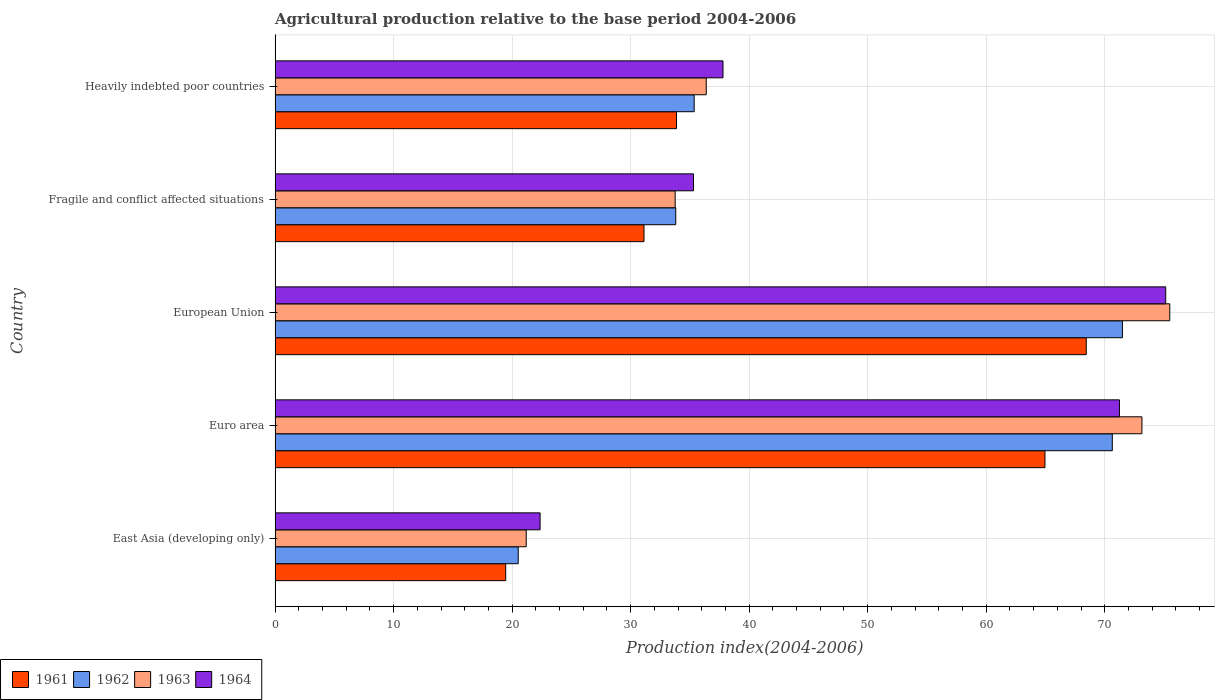How many different coloured bars are there?
Keep it short and to the point. 4. How many groups of bars are there?
Provide a succinct answer. 5. Are the number of bars on each tick of the Y-axis equal?
Provide a succinct answer. Yes. How many bars are there on the 3rd tick from the top?
Your response must be concise. 4. What is the label of the 2nd group of bars from the top?
Your answer should be compact. Fragile and conflict affected situations. What is the agricultural production index in 1963 in Euro area?
Keep it short and to the point. 73.14. Across all countries, what is the maximum agricultural production index in 1963?
Provide a succinct answer. 75.49. Across all countries, what is the minimum agricultural production index in 1961?
Offer a very short reply. 19.46. In which country was the agricultural production index in 1962 maximum?
Ensure brevity in your answer.  European Union. In which country was the agricultural production index in 1962 minimum?
Give a very brief answer. East Asia (developing only). What is the total agricultural production index in 1961 in the graph?
Your answer should be compact. 217.86. What is the difference between the agricultural production index in 1962 in Euro area and that in European Union?
Ensure brevity in your answer.  -0.85. What is the difference between the agricultural production index in 1961 in Heavily indebted poor countries and the agricultural production index in 1964 in East Asia (developing only)?
Offer a very short reply. 11.51. What is the average agricultural production index in 1962 per country?
Your response must be concise. 46.36. What is the difference between the agricultural production index in 1962 and agricultural production index in 1963 in Fragile and conflict affected situations?
Give a very brief answer. 0.05. What is the ratio of the agricultural production index in 1961 in East Asia (developing only) to that in Heavily indebted poor countries?
Your answer should be very brief. 0.57. What is the difference between the highest and the second highest agricultural production index in 1963?
Your answer should be very brief. 2.35. What is the difference between the highest and the lowest agricultural production index in 1962?
Make the answer very short. 50.98. In how many countries, is the agricultural production index in 1964 greater than the average agricultural production index in 1964 taken over all countries?
Your response must be concise. 2. Is the sum of the agricultural production index in 1963 in Euro area and European Union greater than the maximum agricultural production index in 1964 across all countries?
Offer a terse response. Yes. Is it the case that in every country, the sum of the agricultural production index in 1963 and agricultural production index in 1962 is greater than the sum of agricultural production index in 1961 and agricultural production index in 1964?
Make the answer very short. No. What does the 1st bar from the top in European Union represents?
Keep it short and to the point. 1964. Is it the case that in every country, the sum of the agricultural production index in 1963 and agricultural production index in 1964 is greater than the agricultural production index in 1962?
Make the answer very short. Yes. How many countries are there in the graph?
Provide a succinct answer. 5. What is the difference between two consecutive major ticks on the X-axis?
Offer a terse response. 10. Are the values on the major ticks of X-axis written in scientific E-notation?
Your answer should be very brief. No. Does the graph contain any zero values?
Offer a terse response. No. Does the graph contain grids?
Provide a succinct answer. Yes. Where does the legend appear in the graph?
Keep it short and to the point. Bottom left. How are the legend labels stacked?
Keep it short and to the point. Horizontal. What is the title of the graph?
Your answer should be very brief. Agricultural production relative to the base period 2004-2006. Does "1969" appear as one of the legend labels in the graph?
Your answer should be compact. No. What is the label or title of the X-axis?
Your answer should be very brief. Production index(2004-2006). What is the Production index(2004-2006) in 1961 in East Asia (developing only)?
Your answer should be very brief. 19.46. What is the Production index(2004-2006) of 1962 in East Asia (developing only)?
Keep it short and to the point. 20.51. What is the Production index(2004-2006) of 1963 in East Asia (developing only)?
Give a very brief answer. 21.19. What is the Production index(2004-2006) of 1964 in East Asia (developing only)?
Your answer should be very brief. 22.36. What is the Production index(2004-2006) in 1961 in Euro area?
Your answer should be compact. 64.96. What is the Production index(2004-2006) in 1962 in Euro area?
Give a very brief answer. 70.64. What is the Production index(2004-2006) in 1963 in Euro area?
Your answer should be very brief. 73.14. What is the Production index(2004-2006) of 1964 in Euro area?
Your answer should be compact. 71.24. What is the Production index(2004-2006) of 1961 in European Union?
Offer a terse response. 68.44. What is the Production index(2004-2006) of 1962 in European Union?
Offer a very short reply. 71.49. What is the Production index(2004-2006) of 1963 in European Union?
Your answer should be very brief. 75.49. What is the Production index(2004-2006) in 1964 in European Union?
Offer a very short reply. 75.15. What is the Production index(2004-2006) of 1961 in Fragile and conflict affected situations?
Your answer should be very brief. 31.13. What is the Production index(2004-2006) of 1962 in Fragile and conflict affected situations?
Offer a very short reply. 33.81. What is the Production index(2004-2006) of 1963 in Fragile and conflict affected situations?
Your answer should be compact. 33.76. What is the Production index(2004-2006) of 1964 in Fragile and conflict affected situations?
Make the answer very short. 35.31. What is the Production index(2004-2006) in 1961 in Heavily indebted poor countries?
Provide a succinct answer. 33.87. What is the Production index(2004-2006) in 1962 in Heavily indebted poor countries?
Your answer should be compact. 35.36. What is the Production index(2004-2006) in 1963 in Heavily indebted poor countries?
Keep it short and to the point. 36.38. What is the Production index(2004-2006) of 1964 in Heavily indebted poor countries?
Your answer should be compact. 37.79. Across all countries, what is the maximum Production index(2004-2006) of 1961?
Ensure brevity in your answer.  68.44. Across all countries, what is the maximum Production index(2004-2006) of 1962?
Ensure brevity in your answer.  71.49. Across all countries, what is the maximum Production index(2004-2006) of 1963?
Offer a terse response. 75.49. Across all countries, what is the maximum Production index(2004-2006) of 1964?
Provide a short and direct response. 75.15. Across all countries, what is the minimum Production index(2004-2006) of 1961?
Your answer should be compact. 19.46. Across all countries, what is the minimum Production index(2004-2006) in 1962?
Your answer should be compact. 20.51. Across all countries, what is the minimum Production index(2004-2006) of 1963?
Offer a terse response. 21.19. Across all countries, what is the minimum Production index(2004-2006) in 1964?
Your answer should be very brief. 22.36. What is the total Production index(2004-2006) of 1961 in the graph?
Give a very brief answer. 217.86. What is the total Production index(2004-2006) of 1962 in the graph?
Your answer should be very brief. 231.82. What is the total Production index(2004-2006) in 1963 in the graph?
Keep it short and to the point. 239.95. What is the total Production index(2004-2006) in 1964 in the graph?
Your answer should be very brief. 241.85. What is the difference between the Production index(2004-2006) of 1961 in East Asia (developing only) and that in Euro area?
Offer a terse response. -45.5. What is the difference between the Production index(2004-2006) in 1962 in East Asia (developing only) and that in Euro area?
Offer a very short reply. -50.13. What is the difference between the Production index(2004-2006) in 1963 in East Asia (developing only) and that in Euro area?
Your answer should be very brief. -51.95. What is the difference between the Production index(2004-2006) in 1964 in East Asia (developing only) and that in Euro area?
Provide a short and direct response. -48.88. What is the difference between the Production index(2004-2006) in 1961 in East Asia (developing only) and that in European Union?
Offer a very short reply. -48.98. What is the difference between the Production index(2004-2006) of 1962 in East Asia (developing only) and that in European Union?
Your answer should be compact. -50.98. What is the difference between the Production index(2004-2006) in 1963 in East Asia (developing only) and that in European Union?
Give a very brief answer. -54.3. What is the difference between the Production index(2004-2006) of 1964 in East Asia (developing only) and that in European Union?
Make the answer very short. -52.79. What is the difference between the Production index(2004-2006) of 1961 in East Asia (developing only) and that in Fragile and conflict affected situations?
Your response must be concise. -11.67. What is the difference between the Production index(2004-2006) of 1962 in East Asia (developing only) and that in Fragile and conflict affected situations?
Provide a short and direct response. -13.29. What is the difference between the Production index(2004-2006) of 1963 in East Asia (developing only) and that in Fragile and conflict affected situations?
Provide a succinct answer. -12.57. What is the difference between the Production index(2004-2006) of 1964 in East Asia (developing only) and that in Fragile and conflict affected situations?
Offer a terse response. -12.95. What is the difference between the Production index(2004-2006) in 1961 in East Asia (developing only) and that in Heavily indebted poor countries?
Ensure brevity in your answer.  -14.41. What is the difference between the Production index(2004-2006) in 1962 in East Asia (developing only) and that in Heavily indebted poor countries?
Provide a short and direct response. -14.85. What is the difference between the Production index(2004-2006) in 1963 in East Asia (developing only) and that in Heavily indebted poor countries?
Give a very brief answer. -15.19. What is the difference between the Production index(2004-2006) of 1964 in East Asia (developing only) and that in Heavily indebted poor countries?
Offer a terse response. -15.43. What is the difference between the Production index(2004-2006) of 1961 in Euro area and that in European Union?
Offer a very short reply. -3.48. What is the difference between the Production index(2004-2006) of 1962 in Euro area and that in European Union?
Your answer should be compact. -0.85. What is the difference between the Production index(2004-2006) in 1963 in Euro area and that in European Union?
Ensure brevity in your answer.  -2.35. What is the difference between the Production index(2004-2006) of 1964 in Euro area and that in European Union?
Offer a very short reply. -3.9. What is the difference between the Production index(2004-2006) in 1961 in Euro area and that in Fragile and conflict affected situations?
Give a very brief answer. 33.83. What is the difference between the Production index(2004-2006) of 1962 in Euro area and that in Fragile and conflict affected situations?
Your response must be concise. 36.83. What is the difference between the Production index(2004-2006) in 1963 in Euro area and that in Fragile and conflict affected situations?
Offer a very short reply. 39.38. What is the difference between the Production index(2004-2006) in 1964 in Euro area and that in Fragile and conflict affected situations?
Your response must be concise. 35.94. What is the difference between the Production index(2004-2006) of 1961 in Euro area and that in Heavily indebted poor countries?
Offer a very short reply. 31.09. What is the difference between the Production index(2004-2006) of 1962 in Euro area and that in Heavily indebted poor countries?
Offer a terse response. 35.28. What is the difference between the Production index(2004-2006) in 1963 in Euro area and that in Heavily indebted poor countries?
Give a very brief answer. 36.76. What is the difference between the Production index(2004-2006) of 1964 in Euro area and that in Heavily indebted poor countries?
Make the answer very short. 33.45. What is the difference between the Production index(2004-2006) of 1961 in European Union and that in Fragile and conflict affected situations?
Your answer should be very brief. 37.32. What is the difference between the Production index(2004-2006) in 1962 in European Union and that in Fragile and conflict affected situations?
Offer a very short reply. 37.69. What is the difference between the Production index(2004-2006) in 1963 in European Union and that in Fragile and conflict affected situations?
Your answer should be very brief. 41.73. What is the difference between the Production index(2004-2006) in 1964 in European Union and that in Fragile and conflict affected situations?
Keep it short and to the point. 39.84. What is the difference between the Production index(2004-2006) of 1961 in European Union and that in Heavily indebted poor countries?
Make the answer very short. 34.57. What is the difference between the Production index(2004-2006) of 1962 in European Union and that in Heavily indebted poor countries?
Your answer should be compact. 36.13. What is the difference between the Production index(2004-2006) in 1963 in European Union and that in Heavily indebted poor countries?
Your answer should be very brief. 39.11. What is the difference between the Production index(2004-2006) in 1964 in European Union and that in Heavily indebted poor countries?
Provide a short and direct response. 37.35. What is the difference between the Production index(2004-2006) of 1961 in Fragile and conflict affected situations and that in Heavily indebted poor countries?
Provide a succinct answer. -2.74. What is the difference between the Production index(2004-2006) of 1962 in Fragile and conflict affected situations and that in Heavily indebted poor countries?
Keep it short and to the point. -1.55. What is the difference between the Production index(2004-2006) in 1963 in Fragile and conflict affected situations and that in Heavily indebted poor countries?
Offer a terse response. -2.62. What is the difference between the Production index(2004-2006) in 1964 in Fragile and conflict affected situations and that in Heavily indebted poor countries?
Ensure brevity in your answer.  -2.49. What is the difference between the Production index(2004-2006) of 1961 in East Asia (developing only) and the Production index(2004-2006) of 1962 in Euro area?
Your answer should be compact. -51.18. What is the difference between the Production index(2004-2006) of 1961 in East Asia (developing only) and the Production index(2004-2006) of 1963 in Euro area?
Provide a succinct answer. -53.68. What is the difference between the Production index(2004-2006) of 1961 in East Asia (developing only) and the Production index(2004-2006) of 1964 in Euro area?
Provide a short and direct response. -51.78. What is the difference between the Production index(2004-2006) of 1962 in East Asia (developing only) and the Production index(2004-2006) of 1963 in Euro area?
Keep it short and to the point. -52.63. What is the difference between the Production index(2004-2006) in 1962 in East Asia (developing only) and the Production index(2004-2006) in 1964 in Euro area?
Provide a succinct answer. -50.73. What is the difference between the Production index(2004-2006) of 1963 in East Asia (developing only) and the Production index(2004-2006) of 1964 in Euro area?
Offer a terse response. -50.05. What is the difference between the Production index(2004-2006) of 1961 in East Asia (developing only) and the Production index(2004-2006) of 1962 in European Union?
Give a very brief answer. -52.04. What is the difference between the Production index(2004-2006) in 1961 in East Asia (developing only) and the Production index(2004-2006) in 1963 in European Union?
Your answer should be compact. -56.03. What is the difference between the Production index(2004-2006) in 1961 in East Asia (developing only) and the Production index(2004-2006) in 1964 in European Union?
Keep it short and to the point. -55.69. What is the difference between the Production index(2004-2006) of 1962 in East Asia (developing only) and the Production index(2004-2006) of 1963 in European Union?
Make the answer very short. -54.97. What is the difference between the Production index(2004-2006) in 1962 in East Asia (developing only) and the Production index(2004-2006) in 1964 in European Union?
Offer a terse response. -54.63. What is the difference between the Production index(2004-2006) in 1963 in East Asia (developing only) and the Production index(2004-2006) in 1964 in European Union?
Your response must be concise. -53.96. What is the difference between the Production index(2004-2006) in 1961 in East Asia (developing only) and the Production index(2004-2006) in 1962 in Fragile and conflict affected situations?
Your answer should be very brief. -14.35. What is the difference between the Production index(2004-2006) of 1961 in East Asia (developing only) and the Production index(2004-2006) of 1963 in Fragile and conflict affected situations?
Provide a short and direct response. -14.3. What is the difference between the Production index(2004-2006) of 1961 in East Asia (developing only) and the Production index(2004-2006) of 1964 in Fragile and conflict affected situations?
Give a very brief answer. -15.85. What is the difference between the Production index(2004-2006) of 1962 in East Asia (developing only) and the Production index(2004-2006) of 1963 in Fragile and conflict affected situations?
Give a very brief answer. -13.24. What is the difference between the Production index(2004-2006) in 1962 in East Asia (developing only) and the Production index(2004-2006) in 1964 in Fragile and conflict affected situations?
Ensure brevity in your answer.  -14.79. What is the difference between the Production index(2004-2006) in 1963 in East Asia (developing only) and the Production index(2004-2006) in 1964 in Fragile and conflict affected situations?
Offer a very short reply. -14.12. What is the difference between the Production index(2004-2006) in 1961 in East Asia (developing only) and the Production index(2004-2006) in 1962 in Heavily indebted poor countries?
Your response must be concise. -15.9. What is the difference between the Production index(2004-2006) in 1961 in East Asia (developing only) and the Production index(2004-2006) in 1963 in Heavily indebted poor countries?
Keep it short and to the point. -16.92. What is the difference between the Production index(2004-2006) in 1961 in East Asia (developing only) and the Production index(2004-2006) in 1964 in Heavily indebted poor countries?
Your response must be concise. -18.34. What is the difference between the Production index(2004-2006) of 1962 in East Asia (developing only) and the Production index(2004-2006) of 1963 in Heavily indebted poor countries?
Your response must be concise. -15.86. What is the difference between the Production index(2004-2006) in 1962 in East Asia (developing only) and the Production index(2004-2006) in 1964 in Heavily indebted poor countries?
Offer a terse response. -17.28. What is the difference between the Production index(2004-2006) in 1963 in East Asia (developing only) and the Production index(2004-2006) in 1964 in Heavily indebted poor countries?
Make the answer very short. -16.6. What is the difference between the Production index(2004-2006) in 1961 in Euro area and the Production index(2004-2006) in 1962 in European Union?
Provide a short and direct response. -6.54. What is the difference between the Production index(2004-2006) in 1961 in Euro area and the Production index(2004-2006) in 1963 in European Union?
Provide a succinct answer. -10.53. What is the difference between the Production index(2004-2006) of 1961 in Euro area and the Production index(2004-2006) of 1964 in European Union?
Keep it short and to the point. -10.19. What is the difference between the Production index(2004-2006) in 1962 in Euro area and the Production index(2004-2006) in 1963 in European Union?
Give a very brief answer. -4.85. What is the difference between the Production index(2004-2006) of 1962 in Euro area and the Production index(2004-2006) of 1964 in European Union?
Offer a very short reply. -4.5. What is the difference between the Production index(2004-2006) of 1963 in Euro area and the Production index(2004-2006) of 1964 in European Union?
Keep it short and to the point. -2.01. What is the difference between the Production index(2004-2006) in 1961 in Euro area and the Production index(2004-2006) in 1962 in Fragile and conflict affected situations?
Provide a succinct answer. 31.15. What is the difference between the Production index(2004-2006) of 1961 in Euro area and the Production index(2004-2006) of 1963 in Fragile and conflict affected situations?
Provide a short and direct response. 31.2. What is the difference between the Production index(2004-2006) of 1961 in Euro area and the Production index(2004-2006) of 1964 in Fragile and conflict affected situations?
Offer a terse response. 29.65. What is the difference between the Production index(2004-2006) of 1962 in Euro area and the Production index(2004-2006) of 1963 in Fragile and conflict affected situations?
Offer a terse response. 36.88. What is the difference between the Production index(2004-2006) of 1962 in Euro area and the Production index(2004-2006) of 1964 in Fragile and conflict affected situations?
Your response must be concise. 35.34. What is the difference between the Production index(2004-2006) of 1963 in Euro area and the Production index(2004-2006) of 1964 in Fragile and conflict affected situations?
Provide a succinct answer. 37.83. What is the difference between the Production index(2004-2006) in 1961 in Euro area and the Production index(2004-2006) in 1962 in Heavily indebted poor countries?
Ensure brevity in your answer.  29.6. What is the difference between the Production index(2004-2006) in 1961 in Euro area and the Production index(2004-2006) in 1963 in Heavily indebted poor countries?
Keep it short and to the point. 28.58. What is the difference between the Production index(2004-2006) of 1961 in Euro area and the Production index(2004-2006) of 1964 in Heavily indebted poor countries?
Your answer should be very brief. 27.17. What is the difference between the Production index(2004-2006) of 1962 in Euro area and the Production index(2004-2006) of 1963 in Heavily indebted poor countries?
Provide a short and direct response. 34.26. What is the difference between the Production index(2004-2006) of 1962 in Euro area and the Production index(2004-2006) of 1964 in Heavily indebted poor countries?
Ensure brevity in your answer.  32.85. What is the difference between the Production index(2004-2006) in 1963 in Euro area and the Production index(2004-2006) in 1964 in Heavily indebted poor countries?
Keep it short and to the point. 35.35. What is the difference between the Production index(2004-2006) in 1961 in European Union and the Production index(2004-2006) in 1962 in Fragile and conflict affected situations?
Your response must be concise. 34.64. What is the difference between the Production index(2004-2006) in 1961 in European Union and the Production index(2004-2006) in 1963 in Fragile and conflict affected situations?
Give a very brief answer. 34.69. What is the difference between the Production index(2004-2006) of 1961 in European Union and the Production index(2004-2006) of 1964 in Fragile and conflict affected situations?
Provide a short and direct response. 33.14. What is the difference between the Production index(2004-2006) in 1962 in European Union and the Production index(2004-2006) in 1963 in Fragile and conflict affected situations?
Ensure brevity in your answer.  37.74. What is the difference between the Production index(2004-2006) of 1962 in European Union and the Production index(2004-2006) of 1964 in Fragile and conflict affected situations?
Make the answer very short. 36.19. What is the difference between the Production index(2004-2006) of 1963 in European Union and the Production index(2004-2006) of 1964 in Fragile and conflict affected situations?
Keep it short and to the point. 40.18. What is the difference between the Production index(2004-2006) of 1961 in European Union and the Production index(2004-2006) of 1962 in Heavily indebted poor countries?
Give a very brief answer. 33.08. What is the difference between the Production index(2004-2006) of 1961 in European Union and the Production index(2004-2006) of 1963 in Heavily indebted poor countries?
Ensure brevity in your answer.  32.06. What is the difference between the Production index(2004-2006) in 1961 in European Union and the Production index(2004-2006) in 1964 in Heavily indebted poor countries?
Provide a short and direct response. 30.65. What is the difference between the Production index(2004-2006) in 1962 in European Union and the Production index(2004-2006) in 1963 in Heavily indebted poor countries?
Provide a short and direct response. 35.12. What is the difference between the Production index(2004-2006) of 1962 in European Union and the Production index(2004-2006) of 1964 in Heavily indebted poor countries?
Ensure brevity in your answer.  33.7. What is the difference between the Production index(2004-2006) of 1963 in European Union and the Production index(2004-2006) of 1964 in Heavily indebted poor countries?
Your answer should be very brief. 37.69. What is the difference between the Production index(2004-2006) in 1961 in Fragile and conflict affected situations and the Production index(2004-2006) in 1962 in Heavily indebted poor countries?
Provide a succinct answer. -4.23. What is the difference between the Production index(2004-2006) in 1961 in Fragile and conflict affected situations and the Production index(2004-2006) in 1963 in Heavily indebted poor countries?
Provide a succinct answer. -5.25. What is the difference between the Production index(2004-2006) of 1961 in Fragile and conflict affected situations and the Production index(2004-2006) of 1964 in Heavily indebted poor countries?
Your answer should be very brief. -6.67. What is the difference between the Production index(2004-2006) of 1962 in Fragile and conflict affected situations and the Production index(2004-2006) of 1963 in Heavily indebted poor countries?
Ensure brevity in your answer.  -2.57. What is the difference between the Production index(2004-2006) of 1962 in Fragile and conflict affected situations and the Production index(2004-2006) of 1964 in Heavily indebted poor countries?
Keep it short and to the point. -3.99. What is the difference between the Production index(2004-2006) in 1963 in Fragile and conflict affected situations and the Production index(2004-2006) in 1964 in Heavily indebted poor countries?
Provide a succinct answer. -4.04. What is the average Production index(2004-2006) of 1961 per country?
Your answer should be very brief. 43.57. What is the average Production index(2004-2006) in 1962 per country?
Give a very brief answer. 46.36. What is the average Production index(2004-2006) of 1963 per country?
Your response must be concise. 47.99. What is the average Production index(2004-2006) in 1964 per country?
Keep it short and to the point. 48.37. What is the difference between the Production index(2004-2006) in 1961 and Production index(2004-2006) in 1962 in East Asia (developing only)?
Provide a succinct answer. -1.06. What is the difference between the Production index(2004-2006) of 1961 and Production index(2004-2006) of 1963 in East Asia (developing only)?
Provide a short and direct response. -1.73. What is the difference between the Production index(2004-2006) in 1961 and Production index(2004-2006) in 1964 in East Asia (developing only)?
Offer a terse response. -2.9. What is the difference between the Production index(2004-2006) of 1962 and Production index(2004-2006) of 1963 in East Asia (developing only)?
Give a very brief answer. -0.68. What is the difference between the Production index(2004-2006) in 1962 and Production index(2004-2006) in 1964 in East Asia (developing only)?
Your answer should be very brief. -1.85. What is the difference between the Production index(2004-2006) in 1963 and Production index(2004-2006) in 1964 in East Asia (developing only)?
Your answer should be compact. -1.17. What is the difference between the Production index(2004-2006) in 1961 and Production index(2004-2006) in 1962 in Euro area?
Offer a terse response. -5.68. What is the difference between the Production index(2004-2006) of 1961 and Production index(2004-2006) of 1963 in Euro area?
Offer a terse response. -8.18. What is the difference between the Production index(2004-2006) in 1961 and Production index(2004-2006) in 1964 in Euro area?
Ensure brevity in your answer.  -6.28. What is the difference between the Production index(2004-2006) of 1962 and Production index(2004-2006) of 1963 in Euro area?
Provide a succinct answer. -2.5. What is the difference between the Production index(2004-2006) of 1962 and Production index(2004-2006) of 1964 in Euro area?
Provide a short and direct response. -0.6. What is the difference between the Production index(2004-2006) in 1963 and Production index(2004-2006) in 1964 in Euro area?
Provide a succinct answer. 1.9. What is the difference between the Production index(2004-2006) of 1961 and Production index(2004-2006) of 1962 in European Union?
Your answer should be compact. -3.05. What is the difference between the Production index(2004-2006) of 1961 and Production index(2004-2006) of 1963 in European Union?
Provide a succinct answer. -7.05. What is the difference between the Production index(2004-2006) of 1961 and Production index(2004-2006) of 1964 in European Union?
Give a very brief answer. -6.7. What is the difference between the Production index(2004-2006) of 1962 and Production index(2004-2006) of 1963 in European Union?
Provide a short and direct response. -3.99. What is the difference between the Production index(2004-2006) of 1962 and Production index(2004-2006) of 1964 in European Union?
Provide a short and direct response. -3.65. What is the difference between the Production index(2004-2006) of 1963 and Production index(2004-2006) of 1964 in European Union?
Your response must be concise. 0.34. What is the difference between the Production index(2004-2006) in 1961 and Production index(2004-2006) in 1962 in Fragile and conflict affected situations?
Give a very brief answer. -2.68. What is the difference between the Production index(2004-2006) in 1961 and Production index(2004-2006) in 1963 in Fragile and conflict affected situations?
Keep it short and to the point. -2.63. What is the difference between the Production index(2004-2006) in 1961 and Production index(2004-2006) in 1964 in Fragile and conflict affected situations?
Offer a terse response. -4.18. What is the difference between the Production index(2004-2006) in 1962 and Production index(2004-2006) in 1963 in Fragile and conflict affected situations?
Your answer should be compact. 0.05. What is the difference between the Production index(2004-2006) of 1962 and Production index(2004-2006) of 1964 in Fragile and conflict affected situations?
Offer a terse response. -1.5. What is the difference between the Production index(2004-2006) of 1963 and Production index(2004-2006) of 1964 in Fragile and conflict affected situations?
Give a very brief answer. -1.55. What is the difference between the Production index(2004-2006) of 1961 and Production index(2004-2006) of 1962 in Heavily indebted poor countries?
Ensure brevity in your answer.  -1.49. What is the difference between the Production index(2004-2006) of 1961 and Production index(2004-2006) of 1963 in Heavily indebted poor countries?
Make the answer very short. -2.51. What is the difference between the Production index(2004-2006) of 1961 and Production index(2004-2006) of 1964 in Heavily indebted poor countries?
Make the answer very short. -3.92. What is the difference between the Production index(2004-2006) in 1962 and Production index(2004-2006) in 1963 in Heavily indebted poor countries?
Offer a very short reply. -1.02. What is the difference between the Production index(2004-2006) in 1962 and Production index(2004-2006) in 1964 in Heavily indebted poor countries?
Offer a terse response. -2.43. What is the difference between the Production index(2004-2006) of 1963 and Production index(2004-2006) of 1964 in Heavily indebted poor countries?
Ensure brevity in your answer.  -1.42. What is the ratio of the Production index(2004-2006) in 1961 in East Asia (developing only) to that in Euro area?
Keep it short and to the point. 0.3. What is the ratio of the Production index(2004-2006) of 1962 in East Asia (developing only) to that in Euro area?
Offer a very short reply. 0.29. What is the ratio of the Production index(2004-2006) in 1963 in East Asia (developing only) to that in Euro area?
Your answer should be very brief. 0.29. What is the ratio of the Production index(2004-2006) in 1964 in East Asia (developing only) to that in Euro area?
Your answer should be compact. 0.31. What is the ratio of the Production index(2004-2006) in 1961 in East Asia (developing only) to that in European Union?
Give a very brief answer. 0.28. What is the ratio of the Production index(2004-2006) in 1962 in East Asia (developing only) to that in European Union?
Your answer should be compact. 0.29. What is the ratio of the Production index(2004-2006) of 1963 in East Asia (developing only) to that in European Union?
Offer a very short reply. 0.28. What is the ratio of the Production index(2004-2006) of 1964 in East Asia (developing only) to that in European Union?
Make the answer very short. 0.3. What is the ratio of the Production index(2004-2006) in 1961 in East Asia (developing only) to that in Fragile and conflict affected situations?
Offer a very short reply. 0.63. What is the ratio of the Production index(2004-2006) in 1962 in East Asia (developing only) to that in Fragile and conflict affected situations?
Your answer should be very brief. 0.61. What is the ratio of the Production index(2004-2006) in 1963 in East Asia (developing only) to that in Fragile and conflict affected situations?
Offer a terse response. 0.63. What is the ratio of the Production index(2004-2006) in 1964 in East Asia (developing only) to that in Fragile and conflict affected situations?
Offer a terse response. 0.63. What is the ratio of the Production index(2004-2006) in 1961 in East Asia (developing only) to that in Heavily indebted poor countries?
Keep it short and to the point. 0.57. What is the ratio of the Production index(2004-2006) in 1962 in East Asia (developing only) to that in Heavily indebted poor countries?
Offer a very short reply. 0.58. What is the ratio of the Production index(2004-2006) of 1963 in East Asia (developing only) to that in Heavily indebted poor countries?
Make the answer very short. 0.58. What is the ratio of the Production index(2004-2006) of 1964 in East Asia (developing only) to that in Heavily indebted poor countries?
Keep it short and to the point. 0.59. What is the ratio of the Production index(2004-2006) of 1961 in Euro area to that in European Union?
Give a very brief answer. 0.95. What is the ratio of the Production index(2004-2006) of 1962 in Euro area to that in European Union?
Keep it short and to the point. 0.99. What is the ratio of the Production index(2004-2006) of 1963 in Euro area to that in European Union?
Your answer should be compact. 0.97. What is the ratio of the Production index(2004-2006) of 1964 in Euro area to that in European Union?
Ensure brevity in your answer.  0.95. What is the ratio of the Production index(2004-2006) in 1961 in Euro area to that in Fragile and conflict affected situations?
Provide a short and direct response. 2.09. What is the ratio of the Production index(2004-2006) in 1962 in Euro area to that in Fragile and conflict affected situations?
Make the answer very short. 2.09. What is the ratio of the Production index(2004-2006) of 1963 in Euro area to that in Fragile and conflict affected situations?
Your response must be concise. 2.17. What is the ratio of the Production index(2004-2006) in 1964 in Euro area to that in Fragile and conflict affected situations?
Your answer should be very brief. 2.02. What is the ratio of the Production index(2004-2006) in 1961 in Euro area to that in Heavily indebted poor countries?
Provide a succinct answer. 1.92. What is the ratio of the Production index(2004-2006) of 1962 in Euro area to that in Heavily indebted poor countries?
Give a very brief answer. 2. What is the ratio of the Production index(2004-2006) of 1963 in Euro area to that in Heavily indebted poor countries?
Make the answer very short. 2.01. What is the ratio of the Production index(2004-2006) of 1964 in Euro area to that in Heavily indebted poor countries?
Provide a short and direct response. 1.89. What is the ratio of the Production index(2004-2006) of 1961 in European Union to that in Fragile and conflict affected situations?
Make the answer very short. 2.2. What is the ratio of the Production index(2004-2006) in 1962 in European Union to that in Fragile and conflict affected situations?
Offer a terse response. 2.11. What is the ratio of the Production index(2004-2006) in 1963 in European Union to that in Fragile and conflict affected situations?
Your answer should be compact. 2.24. What is the ratio of the Production index(2004-2006) of 1964 in European Union to that in Fragile and conflict affected situations?
Provide a succinct answer. 2.13. What is the ratio of the Production index(2004-2006) of 1961 in European Union to that in Heavily indebted poor countries?
Your response must be concise. 2.02. What is the ratio of the Production index(2004-2006) of 1962 in European Union to that in Heavily indebted poor countries?
Ensure brevity in your answer.  2.02. What is the ratio of the Production index(2004-2006) of 1963 in European Union to that in Heavily indebted poor countries?
Ensure brevity in your answer.  2.08. What is the ratio of the Production index(2004-2006) of 1964 in European Union to that in Heavily indebted poor countries?
Your answer should be compact. 1.99. What is the ratio of the Production index(2004-2006) in 1961 in Fragile and conflict affected situations to that in Heavily indebted poor countries?
Offer a terse response. 0.92. What is the ratio of the Production index(2004-2006) in 1962 in Fragile and conflict affected situations to that in Heavily indebted poor countries?
Make the answer very short. 0.96. What is the ratio of the Production index(2004-2006) of 1963 in Fragile and conflict affected situations to that in Heavily indebted poor countries?
Offer a very short reply. 0.93. What is the ratio of the Production index(2004-2006) of 1964 in Fragile and conflict affected situations to that in Heavily indebted poor countries?
Ensure brevity in your answer.  0.93. What is the difference between the highest and the second highest Production index(2004-2006) of 1961?
Provide a short and direct response. 3.48. What is the difference between the highest and the second highest Production index(2004-2006) of 1962?
Offer a terse response. 0.85. What is the difference between the highest and the second highest Production index(2004-2006) in 1963?
Keep it short and to the point. 2.35. What is the difference between the highest and the second highest Production index(2004-2006) of 1964?
Ensure brevity in your answer.  3.9. What is the difference between the highest and the lowest Production index(2004-2006) in 1961?
Give a very brief answer. 48.98. What is the difference between the highest and the lowest Production index(2004-2006) of 1962?
Your answer should be compact. 50.98. What is the difference between the highest and the lowest Production index(2004-2006) in 1963?
Offer a very short reply. 54.3. What is the difference between the highest and the lowest Production index(2004-2006) of 1964?
Provide a short and direct response. 52.79. 